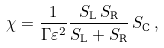<formula> <loc_0><loc_0><loc_500><loc_500>\chi = \frac { 1 } { \Gamma \varepsilon ^ { 2 } } \frac { S _ { \text {L} } \, S _ { \text {R} } } { S _ { \text {L} } + S _ { \text {R} } } \, S _ { \text {C} } \, ,</formula> 